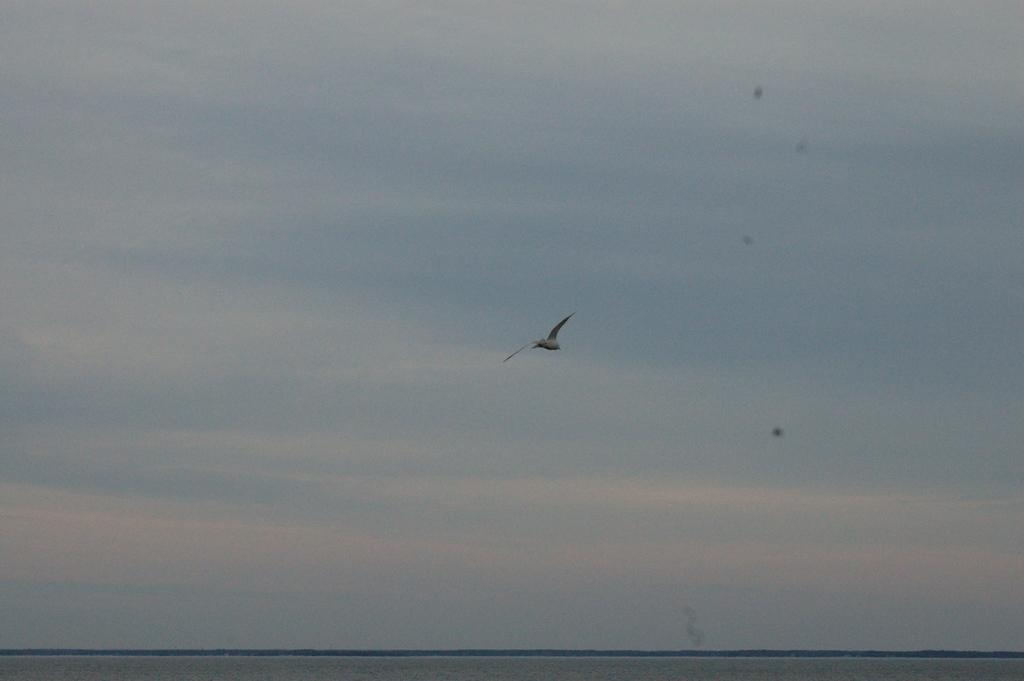What type of animal can be seen in the image? There is a bird in the image. What is the bird doing in the image? The bird is flying in the image. Where is the bird located in the image? The bird is in the sky in the image. What type of celery is being cared for by the women in the image? There are no women or celery present in the image; it only features a bird flying in the sky. 